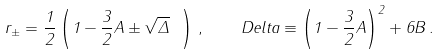<formula> <loc_0><loc_0><loc_500><loc_500>r _ { \pm } = \frac { 1 } { 2 } \left ( 1 - \frac { 3 } { 2 } A \pm \sqrt { \Delta } \ \right ) \, , \quad D e l t a \equiv \left ( 1 - \frac { 3 } { 2 } A \right ) ^ { 2 } + 6 B \, .</formula> 